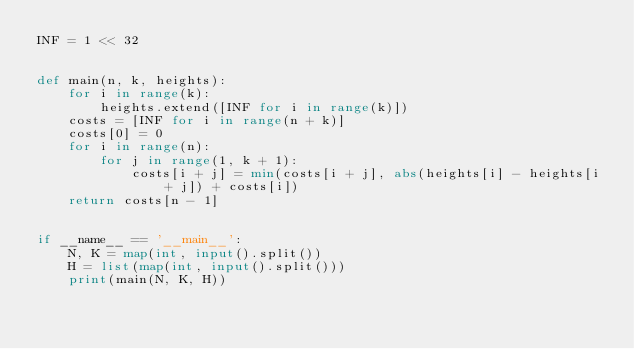Convert code to text. <code><loc_0><loc_0><loc_500><loc_500><_Python_>INF = 1 << 32


def main(n, k, heights):
    for i in range(k):
        heights.extend([INF for i in range(k)])
    costs = [INF for i in range(n + k)]
    costs[0] = 0
    for i in range(n):
        for j in range(1, k + 1):
            costs[i + j] = min(costs[i + j], abs(heights[i] - heights[i + j]) + costs[i])
    return costs[n - 1]


if __name__ == '__main__':
    N, K = map(int, input().split())
    H = list(map(int, input().split()))
    print(main(N, K, H))
</code> 